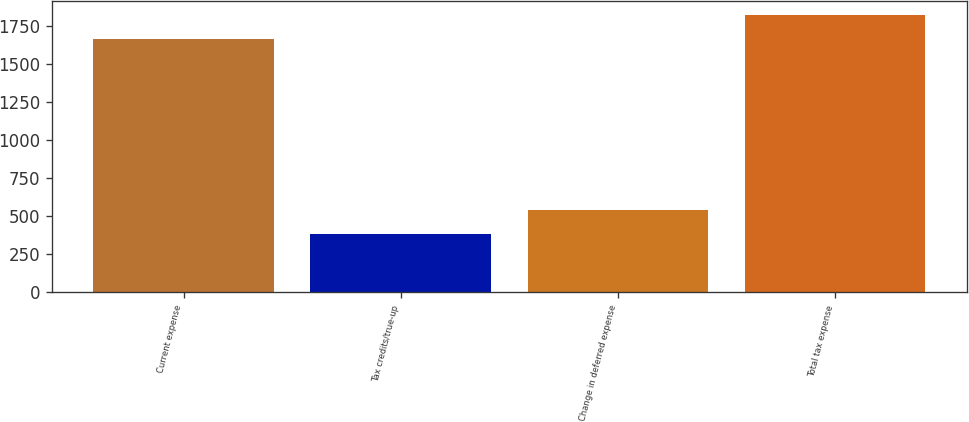Convert chart to OTSL. <chart><loc_0><loc_0><loc_500><loc_500><bar_chart><fcel>Current expense<fcel>Tax credits/true-up<fcel>Change in deferred expense<fcel>Total tax expense<nl><fcel>1662<fcel>383<fcel>542<fcel>1821<nl></chart> 